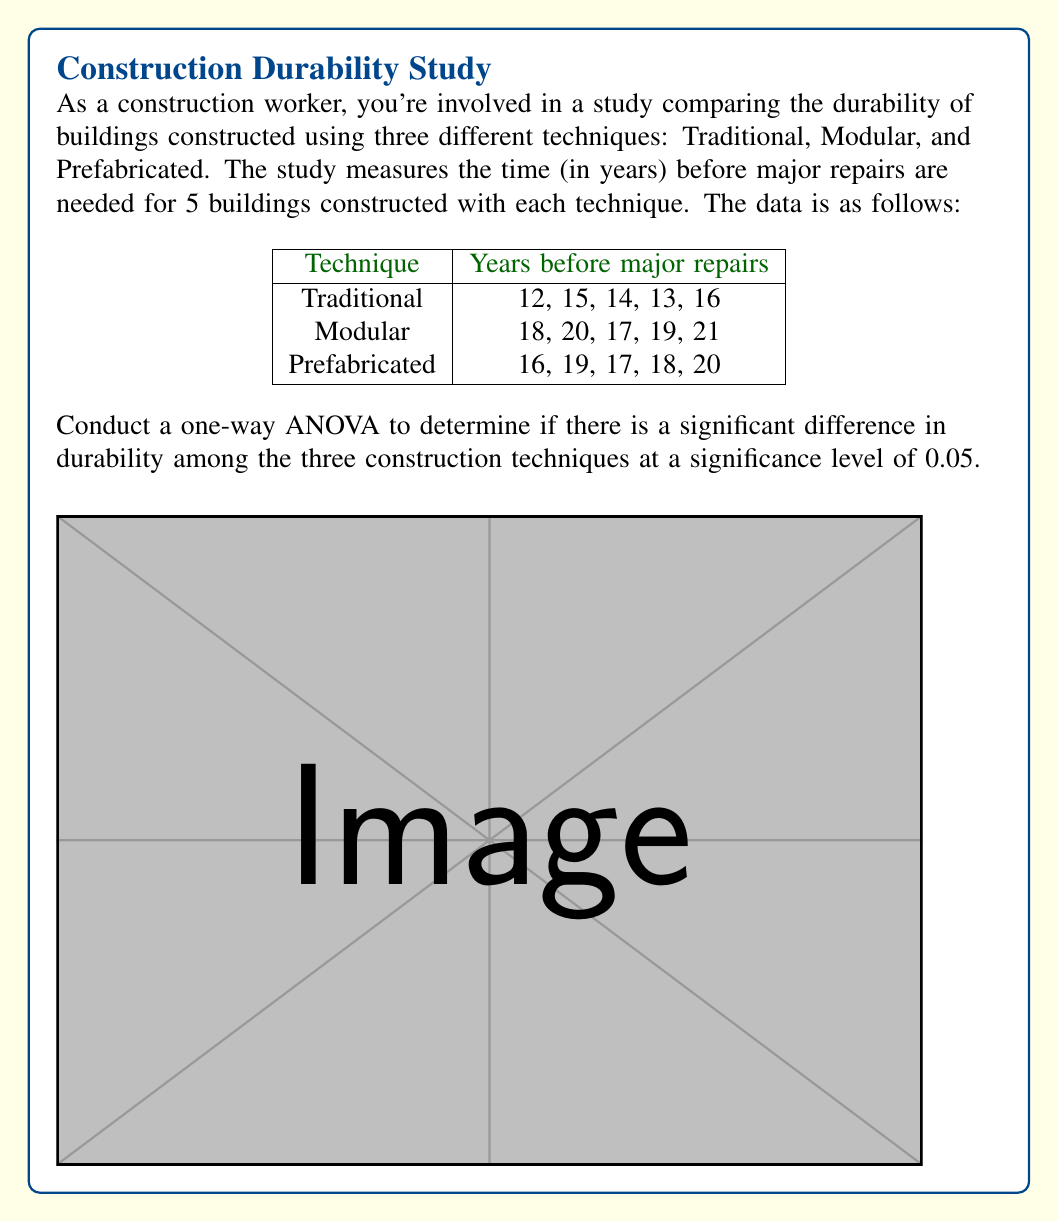Show me your answer to this math problem. Let's conduct the one-way ANOVA step-by-step:

1) First, calculate the mean for each group:
   Traditional: $\bar{x}_1 = 14$
   Modular: $\bar{x}_2 = 19$
   Prefabricated: $\bar{x}_3 = 18$

2) Calculate the grand mean:
   $\bar{x} = \frac{14 + 19 + 18}{3} = 17$

3) Calculate the Sum of Squares Between (SSB):
   $$SSB = \sum_{i=1}^{k} n_i(\bar{x}_i - \bar{x})^2$$
   $$SSB = 5(14-17)^2 + 5(19-17)^2 + 5(18-17)^2 = 75$$

4) Calculate the Sum of Squares Within (SSW):
   $$SSW = \sum_{i=1}^{k} \sum_{j=1}^{n_i} (x_{ij} - \bar{x}_i)^2$$
   $$SSW = 10 + 14 + 11 = 35$$

5) Calculate the Sum of Squares Total (SST):
   $$SST = SSB + SSW = 75 + 35 = 110$$

6) Calculate degrees of freedom:
   $df_{between} = k - 1 = 3 - 1 = 2$
   $df_{within} = N - k = 15 - 3 = 12$
   $df_{total} = N - 1 = 15 - 1 = 14$

7) Calculate Mean Square Between (MSB) and Mean Square Within (MSW):
   $$MSB = \frac{SSB}{df_{between}} = \frac{75}{2} = 37.5$$
   $$MSW = \frac{SSW}{df_{within}} = \frac{35}{12} = 2.92$$

8) Calculate the F-statistic:
   $$F = \frac{MSB}{MSW} = \frac{37.5}{2.92} = 12.84$$

9) Find the critical F-value:
   For $\alpha = 0.05$, $df_{between} = 2$, and $df_{within} = 12$, 
   $F_{critical} = 3.89$ (from F-distribution table)

10) Compare F-statistic to F-critical:
    Since $12.84 > 3.89$, we reject the null hypothesis.
Answer: F(2,12) = 12.84, p < 0.05. Significant difference in durability among techniques. 